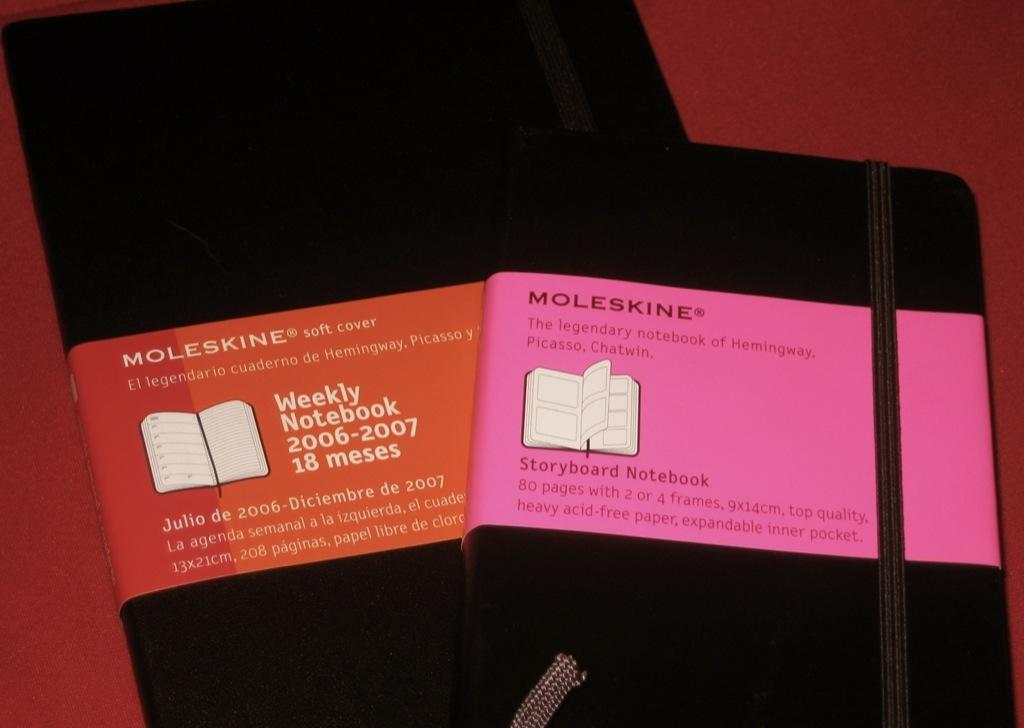Provide a one-sentence caption for the provided image. Moleskine brand note pads have pink and red labels. 